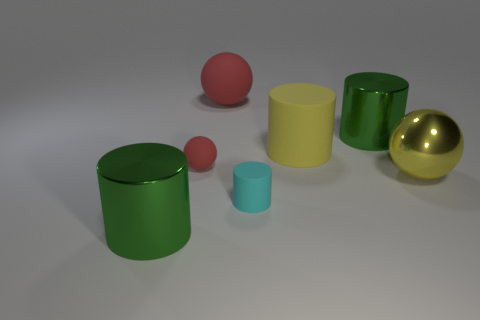What does the arrangement of these objects tell us about perspective and depth? The arrangement of the objects creates a sense of depth due to their varying sizes and overlapping positions. The green cylinders are placed in the foreground, making them appear closer, while the yellow and gold objects seem to be further away. The positioning of the smaller red and cyan cylinders gives the scene a three-dimensional feel, reinforcing perspective. 